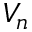Convert formula to latex. <formula><loc_0><loc_0><loc_500><loc_500>V _ { n }</formula> 